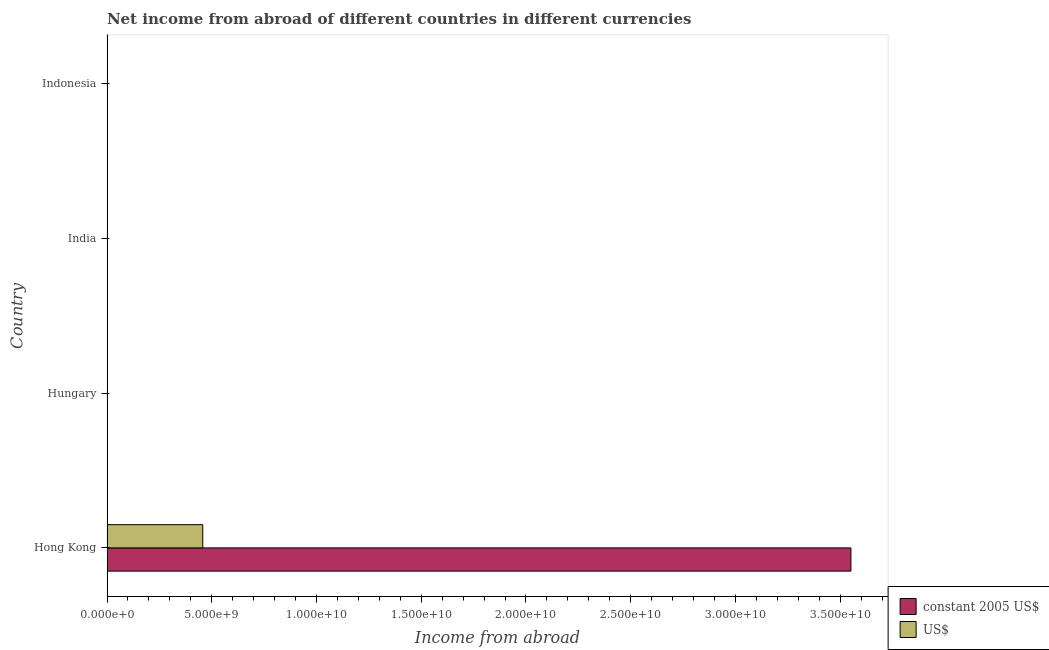How many bars are there on the 1st tick from the top?
Give a very brief answer. 0. In how many cases, is the number of bars for a given country not equal to the number of legend labels?
Your answer should be compact. 3. What is the income from abroad in us$ in Indonesia?
Keep it short and to the point. 0. Across all countries, what is the maximum income from abroad in us$?
Offer a terse response. 4.57e+09. In which country was the income from abroad in constant 2005 us$ maximum?
Your response must be concise. Hong Kong. What is the total income from abroad in us$ in the graph?
Offer a very short reply. 4.57e+09. What is the average income from abroad in us$ per country?
Ensure brevity in your answer.  1.14e+09. What is the difference between the income from abroad in constant 2005 us$ and income from abroad in us$ in Hong Kong?
Your answer should be very brief. 3.09e+1. In how many countries, is the income from abroad in us$ greater than 9000000000 units?
Provide a succinct answer. 0. What is the difference between the highest and the lowest income from abroad in us$?
Offer a terse response. 4.57e+09. In how many countries, is the income from abroad in us$ greater than the average income from abroad in us$ taken over all countries?
Provide a succinct answer. 1. How many bars are there?
Your answer should be very brief. 2. Are all the bars in the graph horizontal?
Make the answer very short. Yes. What is the difference between two consecutive major ticks on the X-axis?
Offer a very short reply. 5.00e+09. Are the values on the major ticks of X-axis written in scientific E-notation?
Your answer should be compact. Yes. Does the graph contain any zero values?
Give a very brief answer. Yes. What is the title of the graph?
Provide a short and direct response. Net income from abroad of different countries in different currencies. Does "Central government" appear as one of the legend labels in the graph?
Provide a short and direct response. No. What is the label or title of the X-axis?
Make the answer very short. Income from abroad. What is the Income from abroad of constant 2005 US$ in Hong Kong?
Ensure brevity in your answer.  3.55e+1. What is the Income from abroad of US$ in Hong Kong?
Ensure brevity in your answer.  4.57e+09. What is the Income from abroad of constant 2005 US$ in India?
Offer a very short reply. 0. What is the Income from abroad of US$ in India?
Provide a succinct answer. 0. What is the Income from abroad of US$ in Indonesia?
Offer a very short reply. 0. Across all countries, what is the maximum Income from abroad of constant 2005 US$?
Give a very brief answer. 3.55e+1. Across all countries, what is the maximum Income from abroad of US$?
Give a very brief answer. 4.57e+09. Across all countries, what is the minimum Income from abroad of US$?
Your answer should be very brief. 0. What is the total Income from abroad of constant 2005 US$ in the graph?
Make the answer very short. 3.55e+1. What is the total Income from abroad in US$ in the graph?
Provide a short and direct response. 4.57e+09. What is the average Income from abroad of constant 2005 US$ per country?
Ensure brevity in your answer.  8.88e+09. What is the average Income from abroad of US$ per country?
Keep it short and to the point. 1.14e+09. What is the difference between the Income from abroad in constant 2005 US$ and Income from abroad in US$ in Hong Kong?
Make the answer very short. 3.09e+1. What is the difference between the highest and the lowest Income from abroad of constant 2005 US$?
Keep it short and to the point. 3.55e+1. What is the difference between the highest and the lowest Income from abroad of US$?
Your answer should be compact. 4.57e+09. 